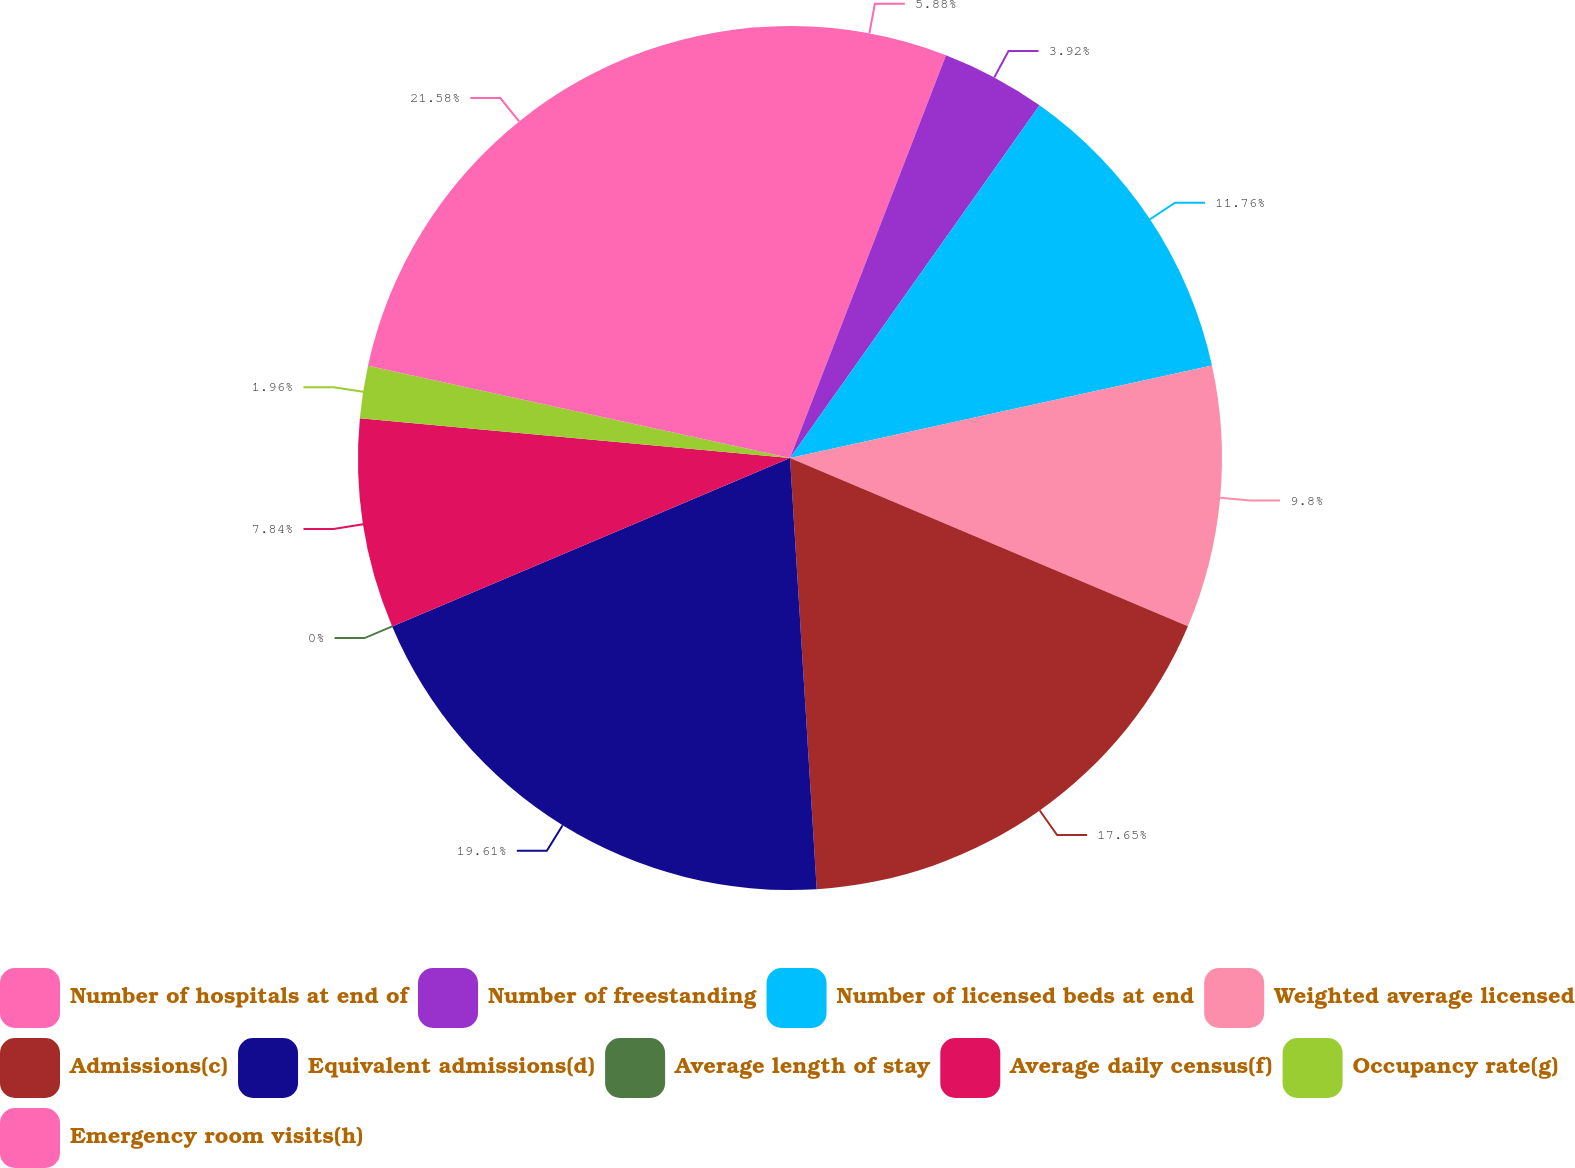Convert chart. <chart><loc_0><loc_0><loc_500><loc_500><pie_chart><fcel>Number of hospitals at end of<fcel>Number of freestanding<fcel>Number of licensed beds at end<fcel>Weighted average licensed<fcel>Admissions(c)<fcel>Equivalent admissions(d)<fcel>Average length of stay<fcel>Average daily census(f)<fcel>Occupancy rate(g)<fcel>Emergency room visits(h)<nl><fcel>5.88%<fcel>3.92%<fcel>11.76%<fcel>9.8%<fcel>17.65%<fcel>19.61%<fcel>0.0%<fcel>7.84%<fcel>1.96%<fcel>21.57%<nl></chart> 